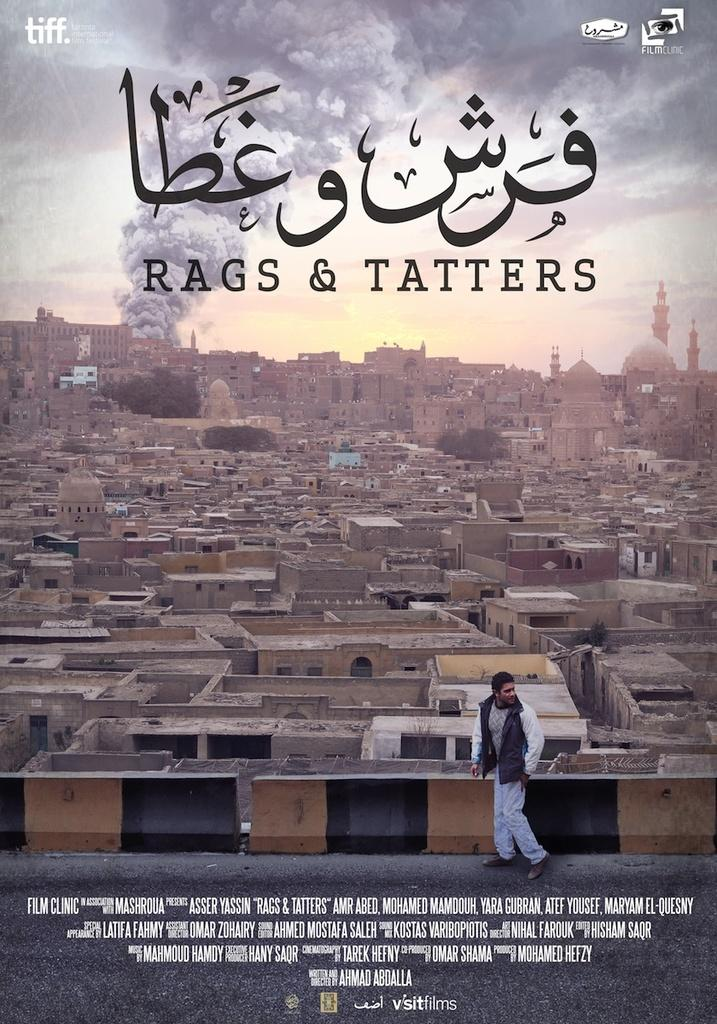<image>
Create a compact narrative representing the image presented. Movie poster that has a man walking in front of a favela titled "Rags & Tatters". 